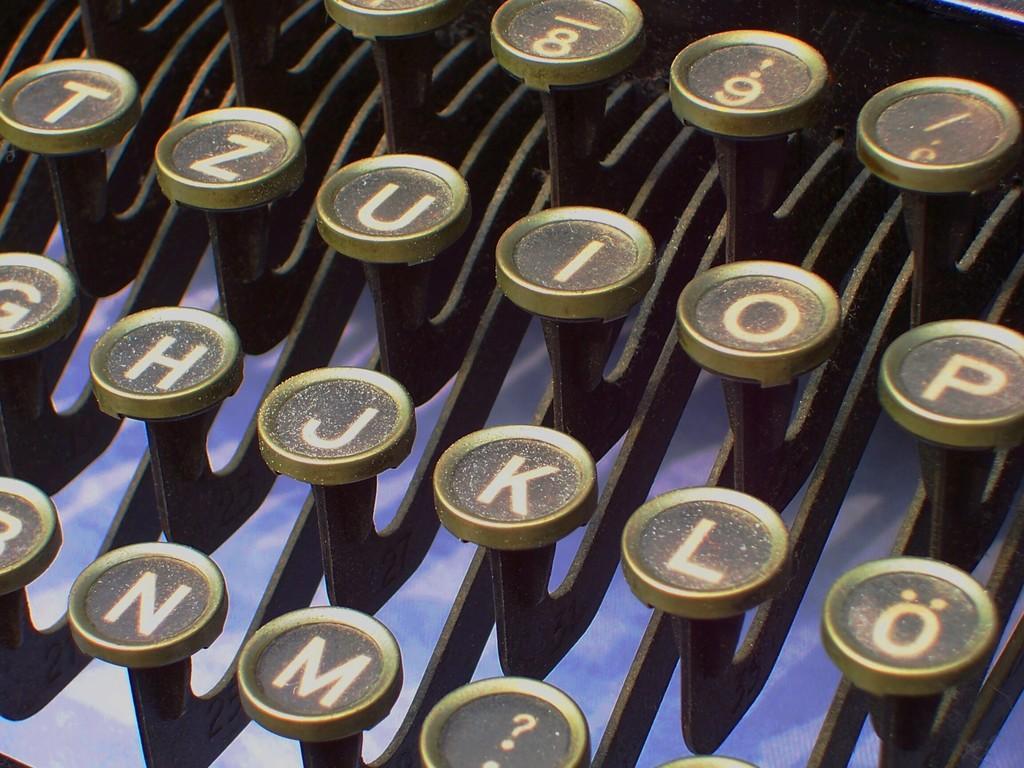How would you summarize this image in a sentence or two? In this image, we can see typewriter keys. 